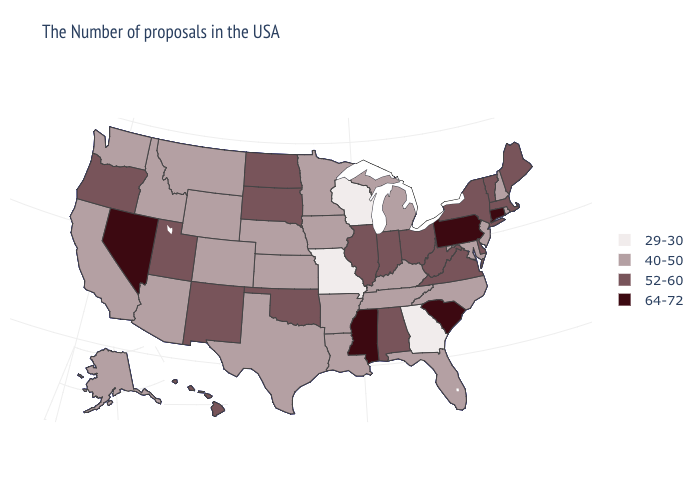What is the value of Maryland?
Write a very short answer. 40-50. Among the states that border Rhode Island , which have the lowest value?
Concise answer only. Massachusetts. What is the lowest value in the Northeast?
Quick response, please. 40-50. Name the states that have a value in the range 64-72?
Be succinct. Connecticut, Pennsylvania, South Carolina, Mississippi, Nevada. Name the states that have a value in the range 29-30?
Be succinct. Georgia, Wisconsin, Missouri. Does Washington have a lower value than New Jersey?
Keep it brief. No. Is the legend a continuous bar?
Keep it brief. No. Among the states that border New Hampshire , which have the lowest value?
Answer briefly. Maine, Massachusetts, Vermont. What is the value of North Carolina?
Write a very short answer. 40-50. Among the states that border Kentucky , does Illinois have the lowest value?
Answer briefly. No. Name the states that have a value in the range 64-72?
Be succinct. Connecticut, Pennsylvania, South Carolina, Mississippi, Nevada. What is the highest value in the USA?
Keep it brief. 64-72. Name the states that have a value in the range 52-60?
Write a very short answer. Maine, Massachusetts, Vermont, New York, Delaware, Virginia, West Virginia, Ohio, Indiana, Alabama, Illinois, Oklahoma, South Dakota, North Dakota, New Mexico, Utah, Oregon, Hawaii. Name the states that have a value in the range 29-30?
Short answer required. Georgia, Wisconsin, Missouri. Name the states that have a value in the range 64-72?
Be succinct. Connecticut, Pennsylvania, South Carolina, Mississippi, Nevada. 